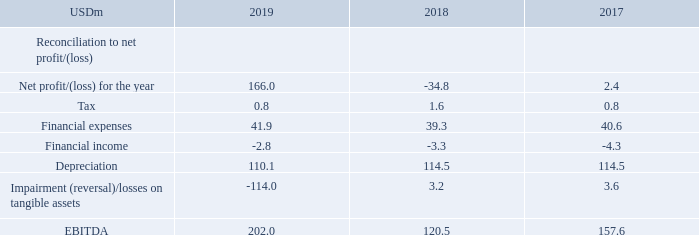EBITDA: TORM defines EBITDA as earnings before financial income and expenses, depreciation, impairment, amortization and taxes. The computation of EBITDA refers to financial income and expenses which the Company deems to be equivalent to “interest” for purposes of presenting EBITDA. Financial expenses consist of interest on borrowings, losses on foreign exchange transactions and bank charges. Financial income consists of interest income and gains on foreign exchange transactions.
EBITDA is used as a supplemental financial measure by Management and external users of financial statements, such as lenders, to assess TORM's operating performance as well as compliance with the financial covenants and restrictions contained in the Company's financing agreements. TORM believes that EBITDA assists Management and investors by increasing comparability of the Company's performance from period to period. This increased comparability is achieved by excluding the potentially disparate effects of interest, depreciation, impairment, amortization and taxes. These are items that could be affected by various changing financing methods and capital structure and which may significantly affect profit/(loss) between periods. Including EBITDA as a measure benefits investors in selecting between investment alternatives.
EBITDA excludes some, but not all, items that affect profit/(loss), and these measures may vary among other companies and not be directly comparable. The following table reconciles EBITDA to net profit/ (loss), the most directly comparable IFRS financial measure, for the periods presented:
How does TORM define EBITDA? As earnings before financial income and expenses, depreciation, impairment, amortization and taxes. What purpose is the EBITDA used for by Management and external users of financial statements, such as lenders? Ebitda is used as a supplemental financial measure by management and external users of financial statements, such as lenders, to assess torm's operating performance as well as compliance with the financial covenants and restrictions contained in the company's financing agreements. For which years in the table is the EBITDA reconciled to net profit/(loss)? 2019, 2018, 2017. In which year was the amount of Financial expenses the largest? 41.9>40.6>39.3
Answer: 2019. What was the change in EBITDA in 2019 from 2018?
Answer scale should be: million. 202.0-120.5
Answer: 81.5. What was the percentage change in EBITDA in 2019 from 2018?
Answer scale should be: percent. (202.0-120.5)/120.5
Answer: 67.63. 